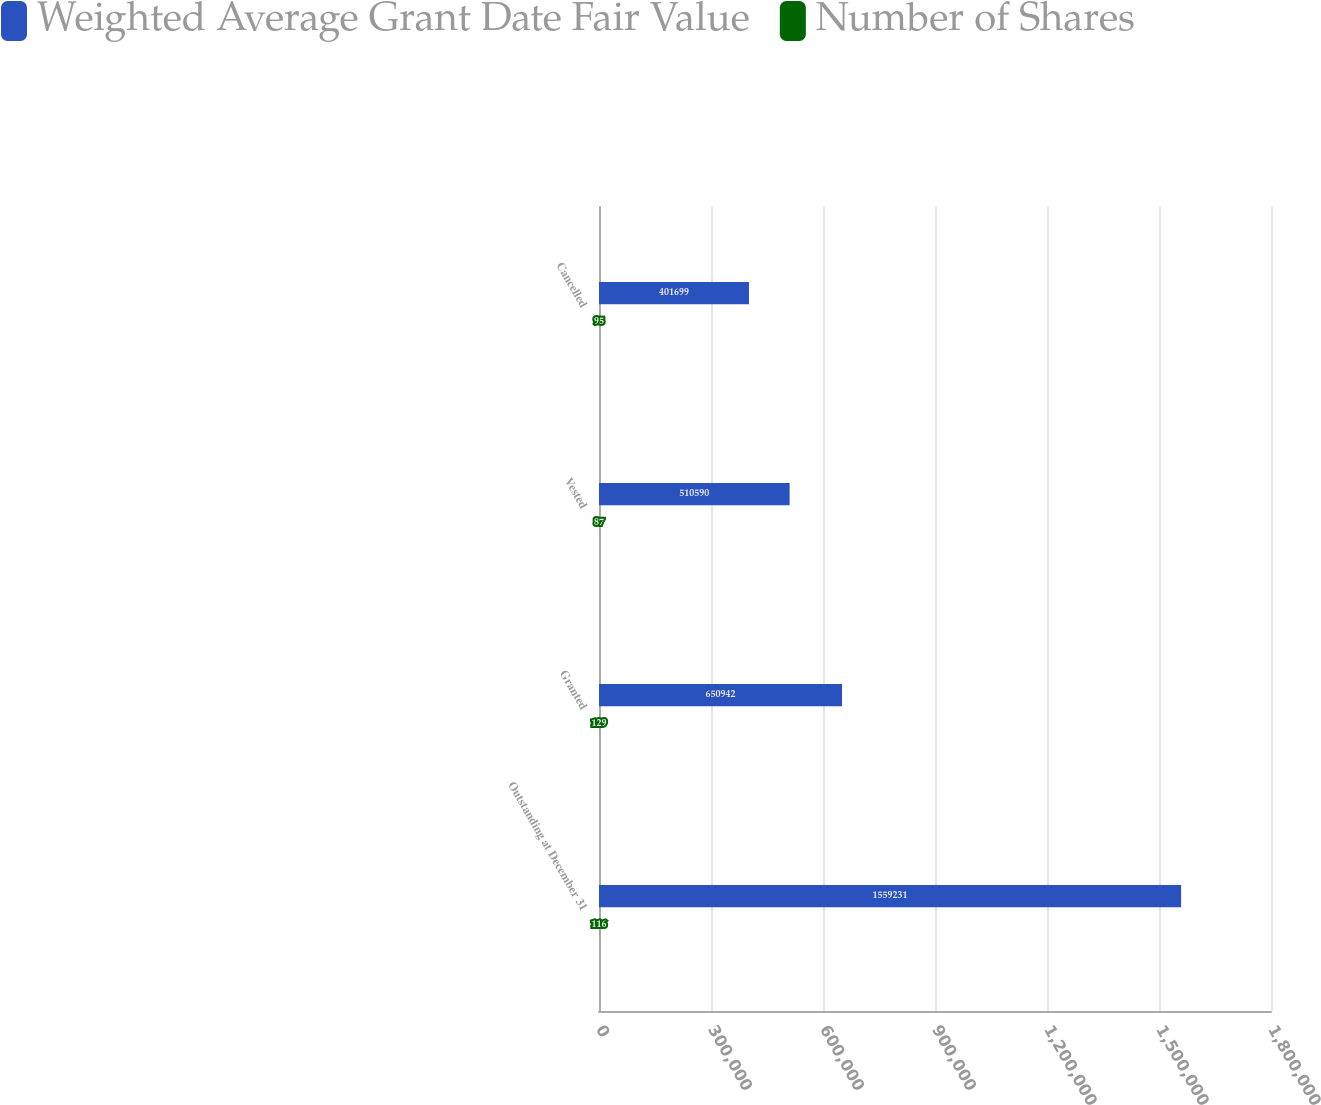<chart> <loc_0><loc_0><loc_500><loc_500><stacked_bar_chart><ecel><fcel>Outstanding at December 31<fcel>Granted<fcel>Vested<fcel>Cancelled<nl><fcel>Weighted Average Grant Date Fair Value<fcel>1.55923e+06<fcel>650942<fcel>510590<fcel>401699<nl><fcel>Number of Shares<fcel>116<fcel>129<fcel>87<fcel>95<nl></chart> 